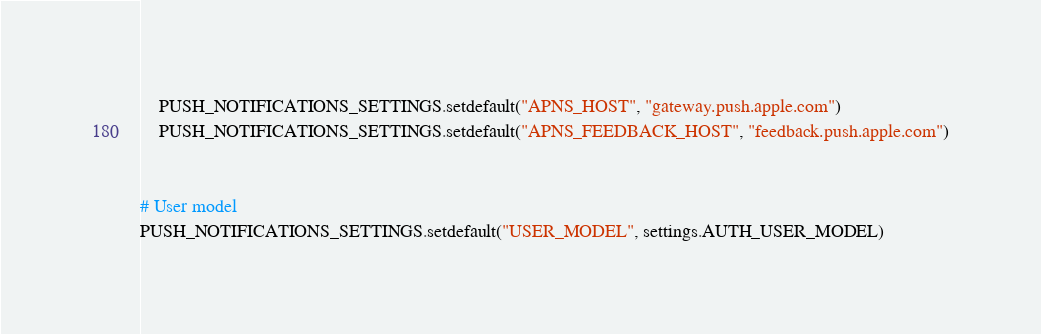<code> <loc_0><loc_0><loc_500><loc_500><_Python_>	PUSH_NOTIFICATIONS_SETTINGS.setdefault("APNS_HOST", "gateway.push.apple.com")
	PUSH_NOTIFICATIONS_SETTINGS.setdefault("APNS_FEEDBACK_HOST", "feedback.push.apple.com")


# User model
PUSH_NOTIFICATIONS_SETTINGS.setdefault("USER_MODEL", settings.AUTH_USER_MODEL)
</code> 